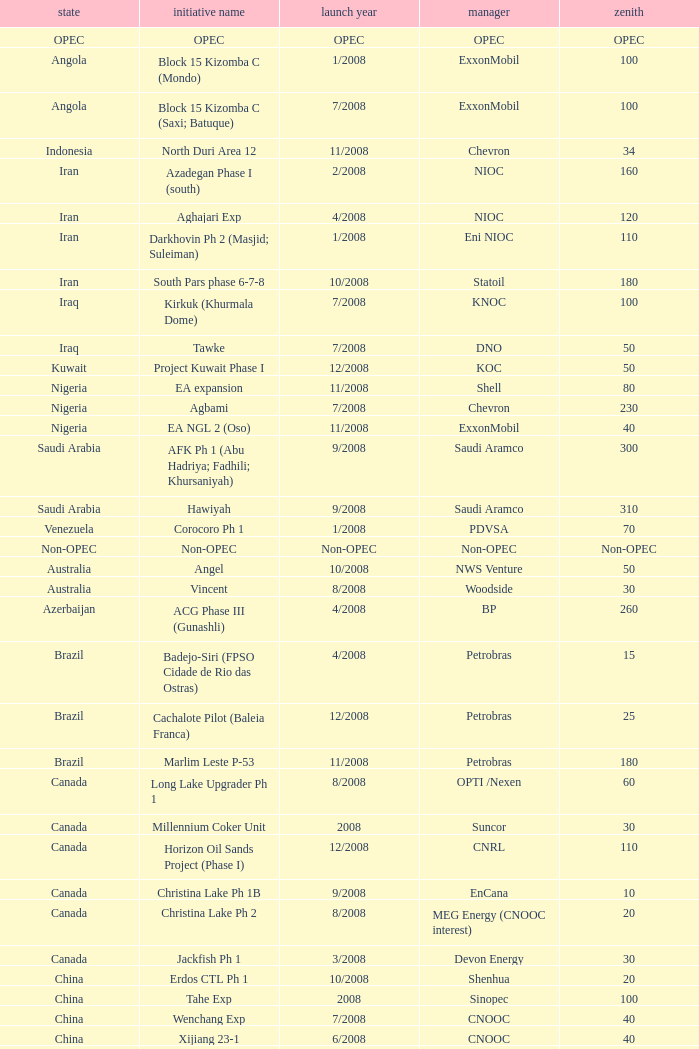Can you provide the project name that involves kazakhstan and has a peak of 150? Dunga. 